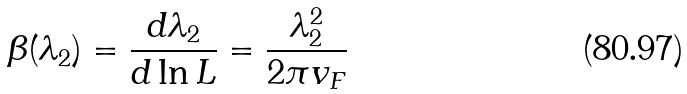Convert formula to latex. <formula><loc_0><loc_0><loc_500><loc_500>\beta ( \lambda _ { 2 } ) = \frac { d \lambda _ { 2 } } { d \ln L } = \frac { \lambda _ { 2 } ^ { 2 } } { 2 \pi v _ { F } }</formula> 